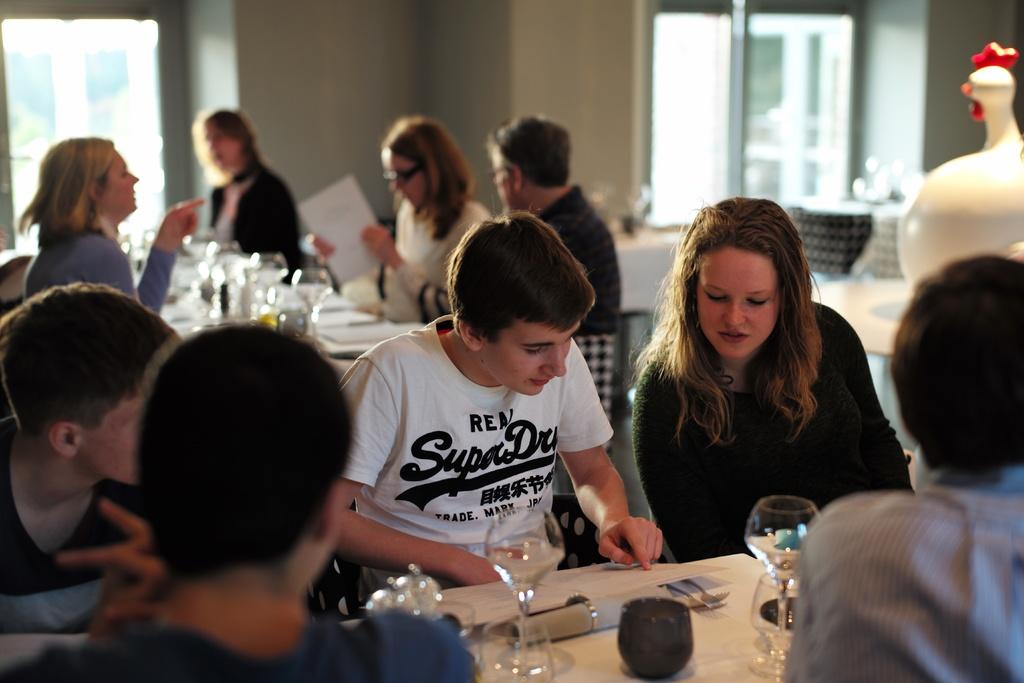How many people are in the image? There is a group of people in the image. What are the people doing in the image? The people are sitting on chairs. What is present in the image besides the people? There is a table in the image. What can be seen on the table? There is a glass on the table. What type of stitch is being used to sew the sense on the look in the image? There is no stitch, sense, or look present in the image; it features a group of people sitting on chairs with a table and a glass. 